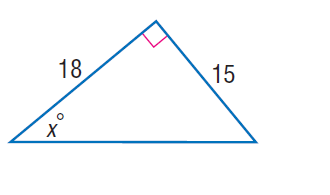Answer the mathemtical geometry problem and directly provide the correct option letter.
Question: Find x.
Choices: A: 39.8 B: 42.5 C: 67.8 D: 68.9 A 